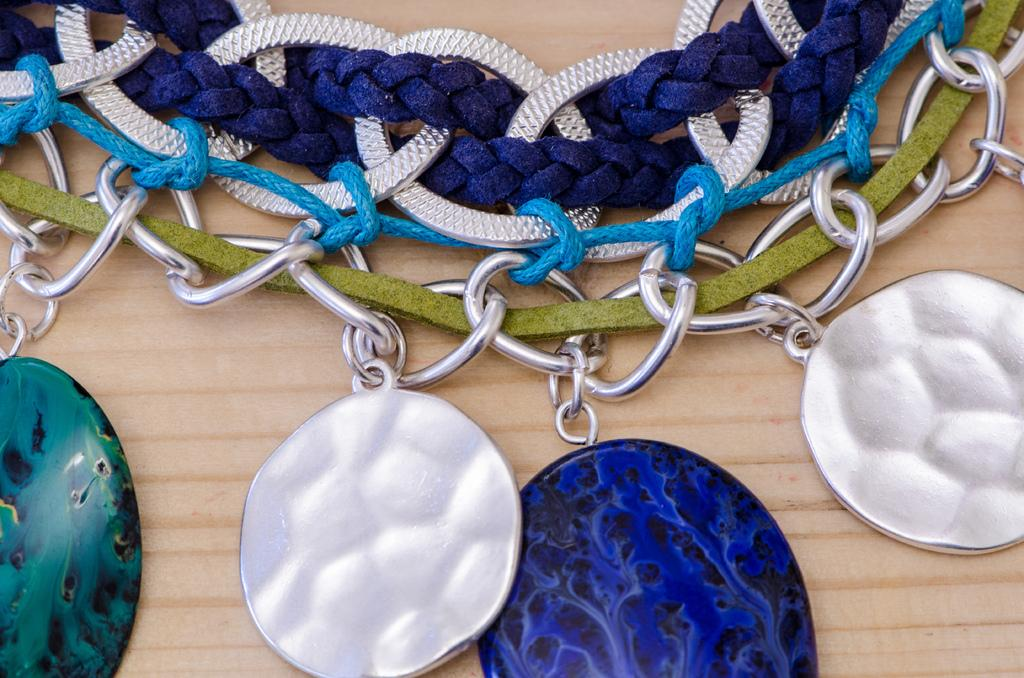What type of objects can be seen in the image? There are knots and chains in the image. Can you describe the appearance of the knots? The knots appear to be intricate and tightly tied. What is the material of the chains? The chains appear to be made of metal. What type of emotion can be seen on the face of the quarter in the image? There is no quarter present in the image, and therefore no face to display emotion. 